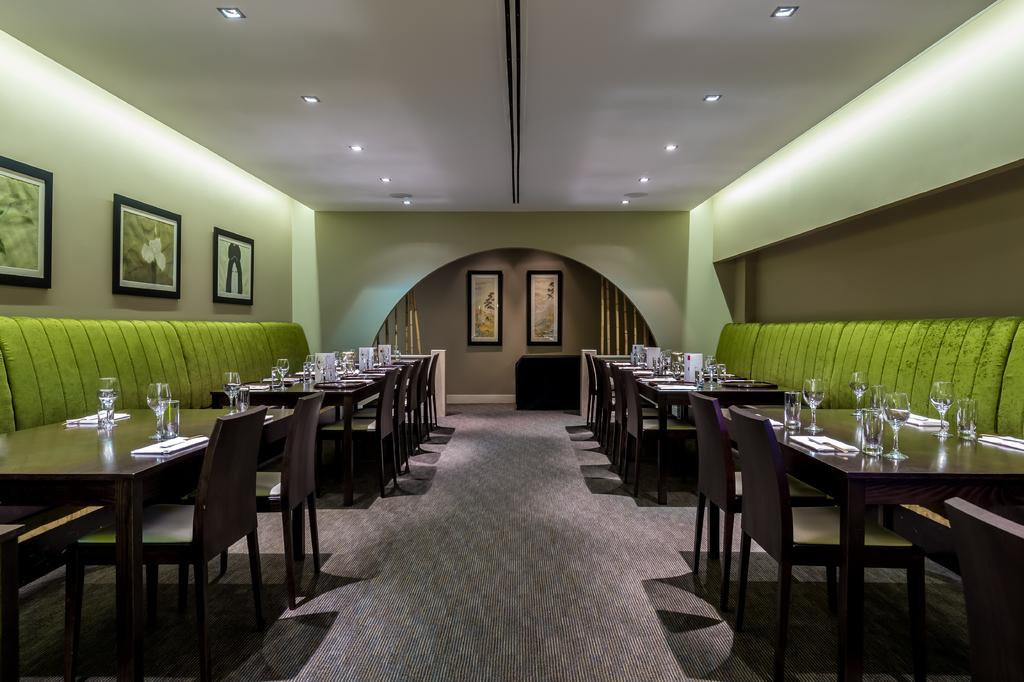What type of furniture is present in the image? There are couches, chairs, and tables in the image. What can be seen on the walls in the image? There are pictures on the walls in the image. What type of lighting is present in the image? There are ceiling lights in the image. What objects are present in the image? There are glasses on the tables in the image. What is the floor covering in the image? The floor has a carpet. What type of can is visible in the image? There is no can present in the image. What is the current month in the image? The image does not provide information about the current month. 